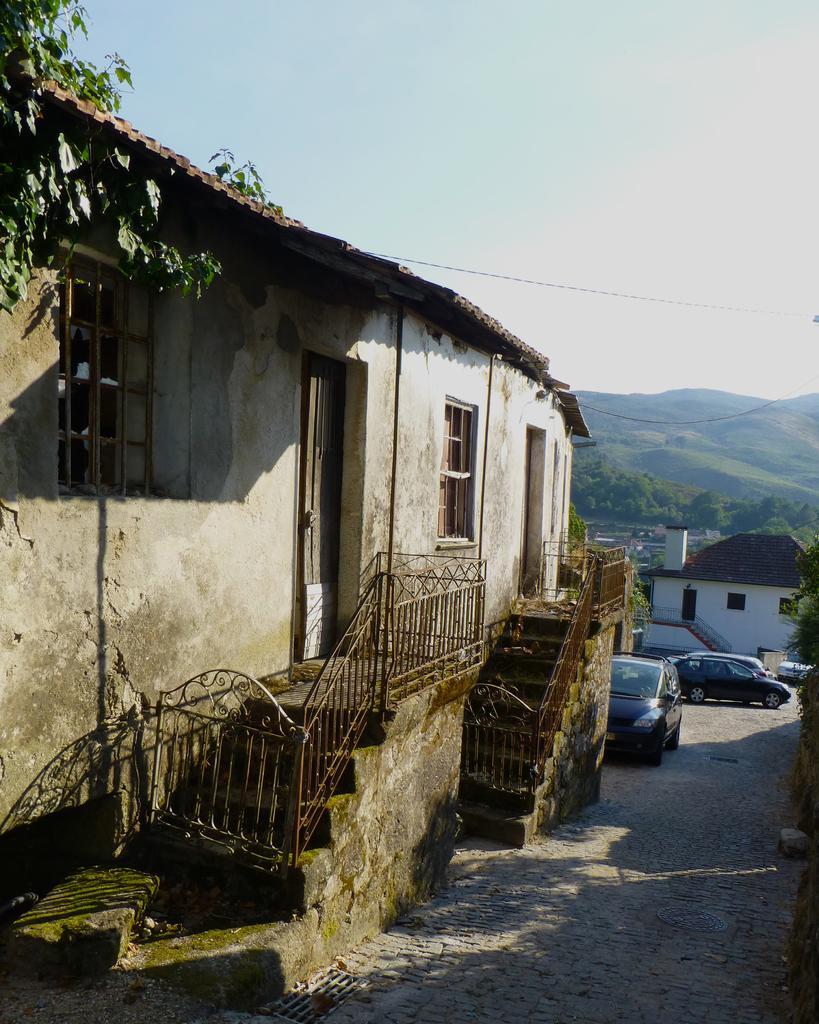Could you give a brief overview of what you see in this image? In the center of the image there is a house. There are windows, staircase. In the background of the image there are mountains. To the right side of the image there is a road. There are cars. 